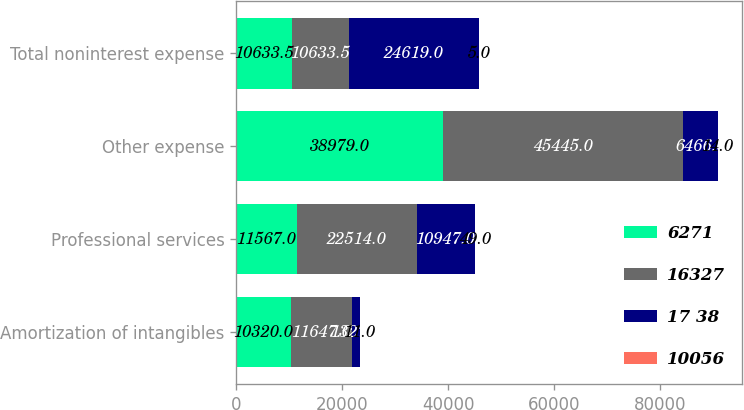Convert chart. <chart><loc_0><loc_0><loc_500><loc_500><stacked_bar_chart><ecel><fcel>Amortization of intangibles<fcel>Professional services<fcel>Other expense<fcel>Total noninterest expense<nl><fcel>6271<fcel>10320<fcel>11567<fcel>38979<fcel>10633.5<nl><fcel>16327<fcel>11647<fcel>22514<fcel>45445<fcel>10633.5<nl><fcel>17 38<fcel>1327<fcel>10947<fcel>6466<fcel>24619<nl><fcel>10056<fcel>11<fcel>49<fcel>14<fcel>5<nl></chart> 